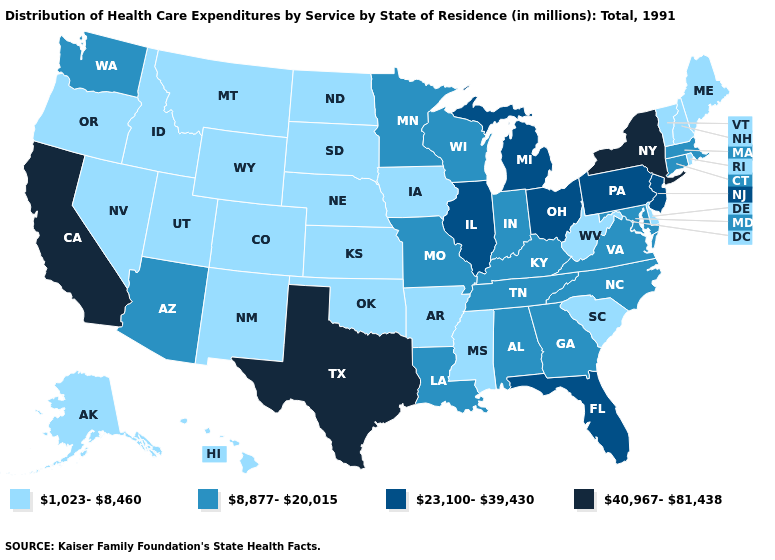Which states have the lowest value in the USA?
Short answer required. Alaska, Arkansas, Colorado, Delaware, Hawaii, Idaho, Iowa, Kansas, Maine, Mississippi, Montana, Nebraska, Nevada, New Hampshire, New Mexico, North Dakota, Oklahoma, Oregon, Rhode Island, South Carolina, South Dakota, Utah, Vermont, West Virginia, Wyoming. Which states have the lowest value in the Northeast?
Write a very short answer. Maine, New Hampshire, Rhode Island, Vermont. Among the states that border Colorado , does Arizona have the lowest value?
Short answer required. No. Does Massachusetts have the lowest value in the USA?
Concise answer only. No. Among the states that border Missouri , which have the highest value?
Concise answer only. Illinois. Among the states that border Idaho , does Washington have the highest value?
Be succinct. Yes. Which states have the highest value in the USA?
Concise answer only. California, New York, Texas. What is the value of Montana?
Answer briefly. 1,023-8,460. What is the lowest value in the USA?
Be succinct. 1,023-8,460. Is the legend a continuous bar?
Quick response, please. No. Does Indiana have the lowest value in the USA?
Answer briefly. No. Does California have the highest value in the West?
Be succinct. Yes. Is the legend a continuous bar?
Answer briefly. No. Name the states that have a value in the range 8,877-20,015?
Be succinct. Alabama, Arizona, Connecticut, Georgia, Indiana, Kentucky, Louisiana, Maryland, Massachusetts, Minnesota, Missouri, North Carolina, Tennessee, Virginia, Washington, Wisconsin. What is the highest value in the South ?
Keep it brief. 40,967-81,438. 